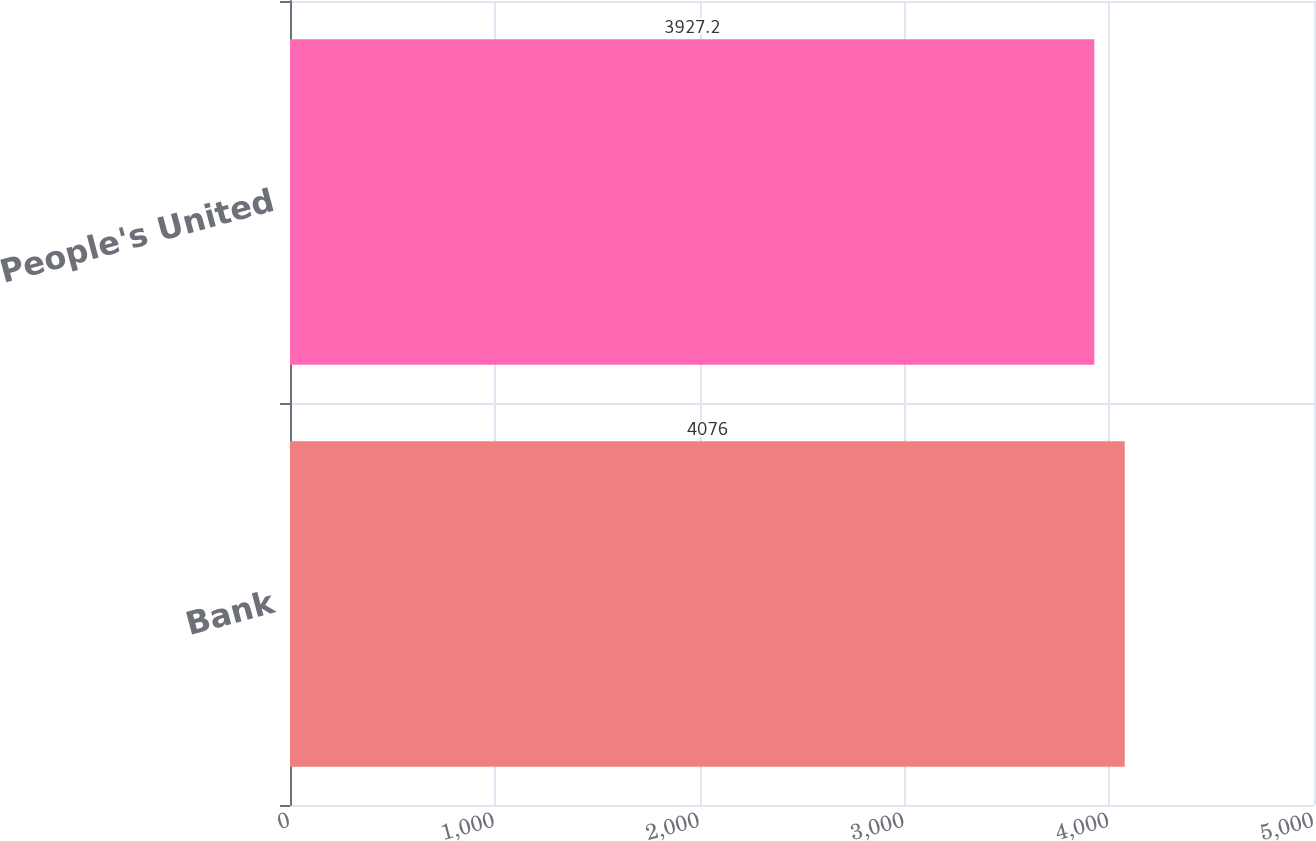<chart> <loc_0><loc_0><loc_500><loc_500><bar_chart><fcel>Bank<fcel>People's United<nl><fcel>4076<fcel>3927.2<nl></chart> 